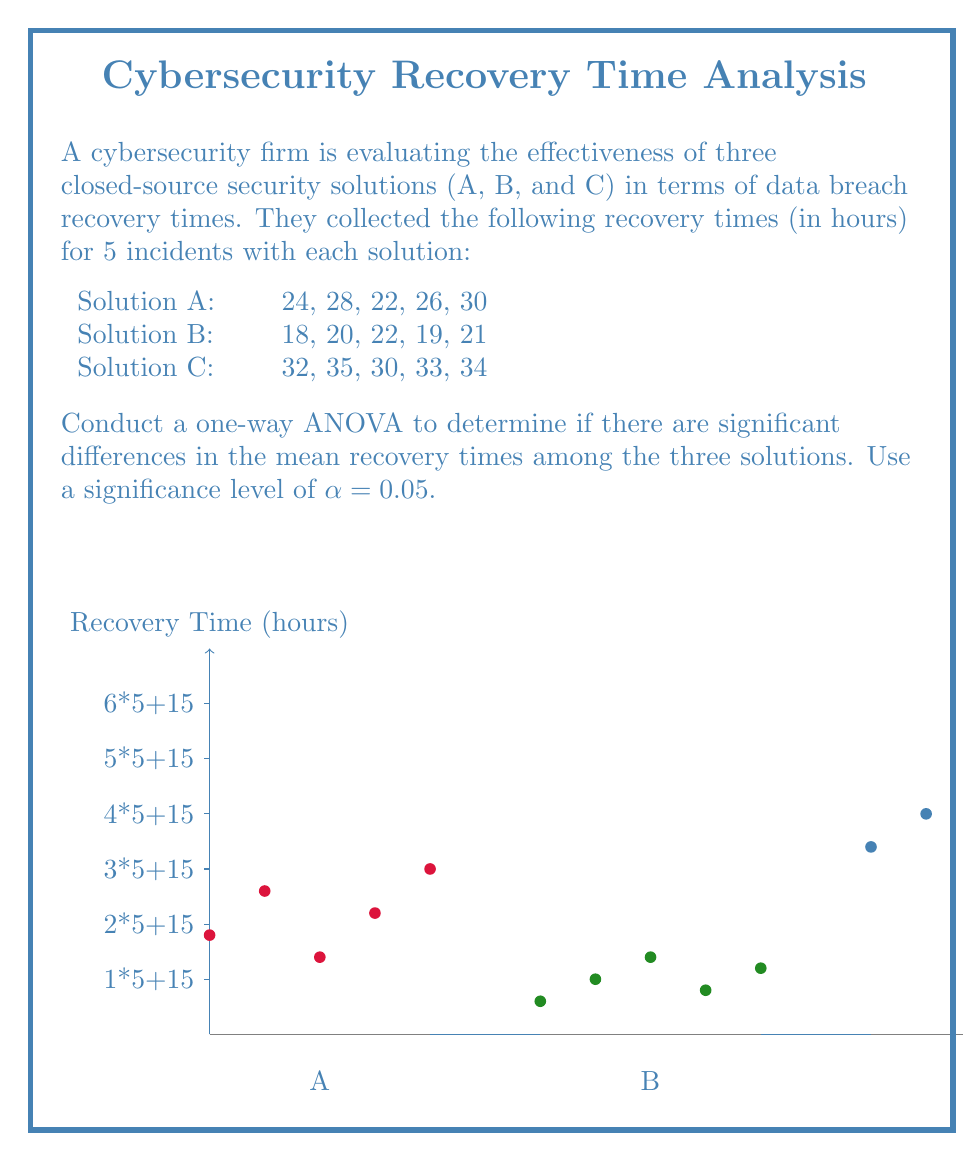Can you answer this question? Let's conduct the one-way ANOVA step-by-step:

1) Calculate the mean for each group:
   $$\bar{X}_A = \frac{24 + 28 + 22 + 26 + 30}{5} = 26$$
   $$\bar{X}_B = \frac{18 + 20 + 22 + 19 + 21}{5} = 20$$
   $$\bar{X}_C = \frac{32 + 35 + 30 + 33 + 34}{5} = 32.8$$

2) Calculate the grand mean:
   $$\bar{X} = \frac{26 + 20 + 32.8}{3} = 26.27$$

3) Calculate the Sum of Squares Between (SSB):
   $$SSB = 5[(26 - 26.27)^2 + (20 - 26.27)^2 + (32.8 - 26.27)^2] = 408.13$$

4) Calculate the Sum of Squares Within (SSW):
   $$SSW_A = (24-26)^2 + (28-26)^2 + (22-26)^2 + (26-26)^2 + (30-26)^2 = 40$$
   $$SSW_B = (18-20)^2 + (20-20)^2 + (22-20)^2 + (19-20)^2 + (21-20)^2 = 10$$
   $$SSW_C = (32-32.8)^2 + (35-32.8)^2 + (30-32.8)^2 + (33-32.8)^2 + (34-32.8)^2 = 16.8$$
   $$SSW = SSW_A + SSW_B + SSW_C = 66.8$$

5) Calculate the degrees of freedom:
   $$df_{between} = k - 1 = 3 - 1 = 2$$
   $$df_{within} = N - k = 15 - 3 = 12$$
   where k is the number of groups and N is the total number of observations.

6) Calculate the Mean Square Between (MSB) and Mean Square Within (MSW):
   $$MSB = \frac{SSB}{df_{between}} = \frac{408.13}{2} = 204.065$$
   $$MSW = \frac{SSW}{df_{within}} = \frac{66.8}{12} = 5.567$$

7) Calculate the F-statistic:
   $$F = \frac{MSB}{MSW} = \frac{204.065}{5.567} = 36.66$$

8) Find the critical F-value:
   For α = 0.05, df₁ = 2, df₂ = 12, the critical F-value is approximately 3.89.

9) Compare the F-statistic to the critical F-value:
   Since 36.66 > 3.89, we reject the null hypothesis.

Therefore, there is strong evidence to suggest that there are significant differences in the mean recovery times among the three closed-source security solutions.
Answer: $F(2,12) = 36.66, p < 0.05$. Reject null hypothesis; significant differences exist. 